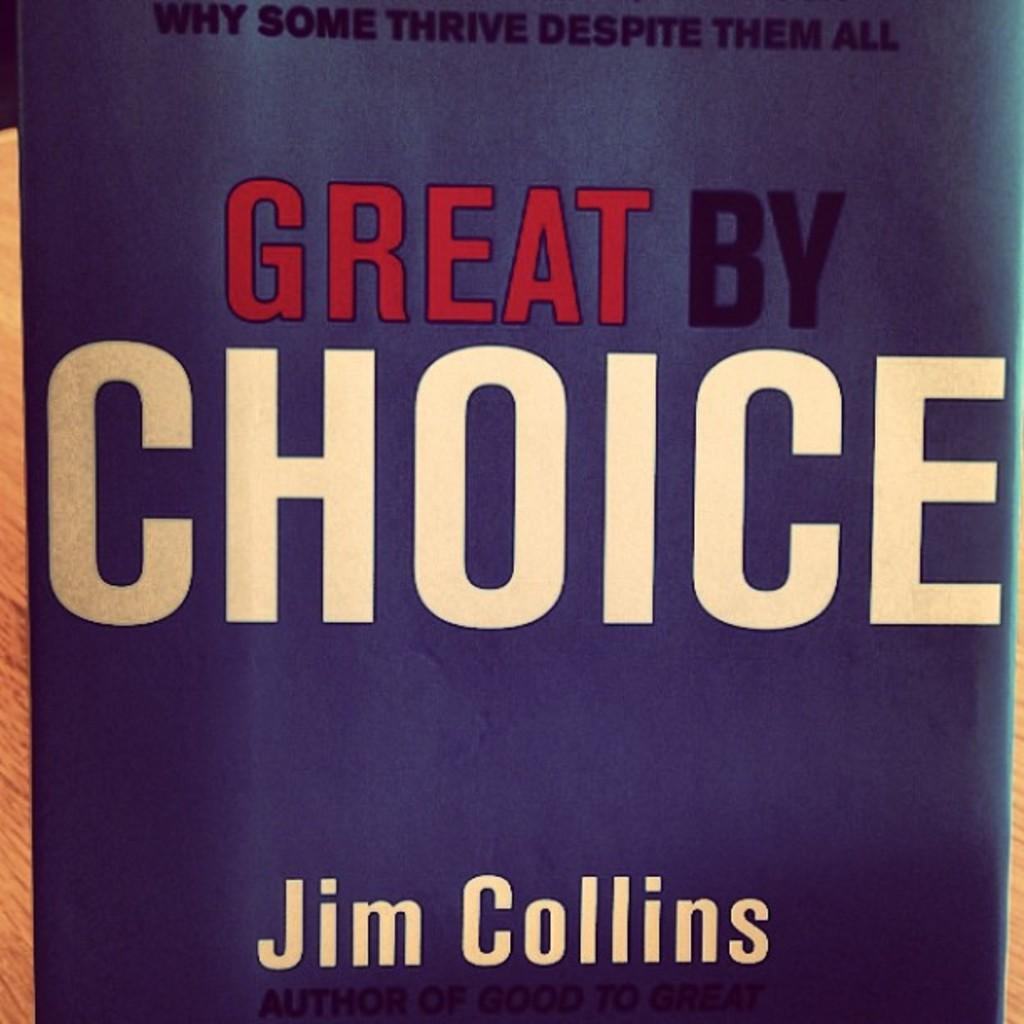Provide a one-sentence caption for the provided image. The book pictured is called Great By Choice by Jim Collins. 